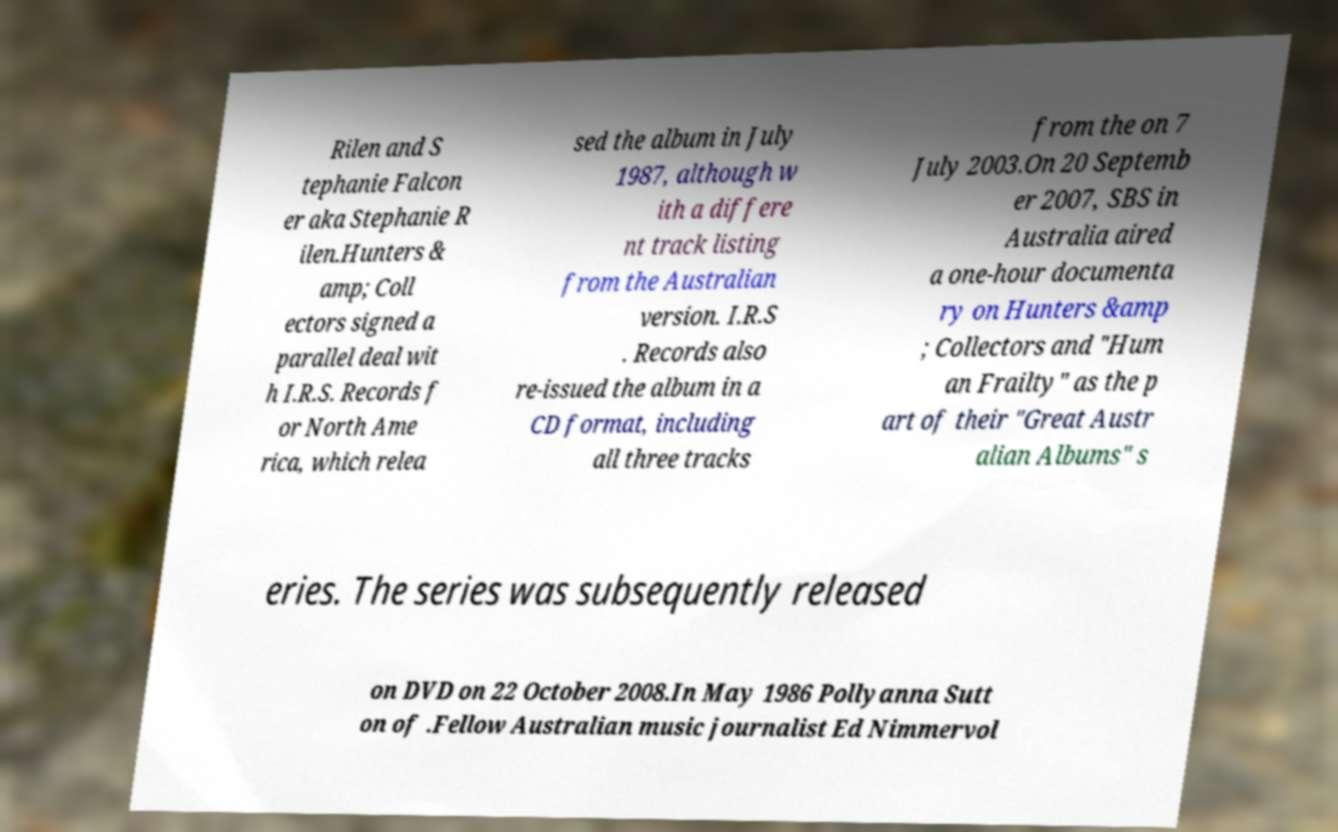There's text embedded in this image that I need extracted. Can you transcribe it verbatim? Rilen and S tephanie Falcon er aka Stephanie R ilen.Hunters & amp; Coll ectors signed a parallel deal wit h I.R.S. Records f or North Ame rica, which relea sed the album in July 1987, although w ith a differe nt track listing from the Australian version. I.R.S . Records also re-issued the album in a CD format, including all three tracks from the on 7 July 2003.On 20 Septemb er 2007, SBS in Australia aired a one-hour documenta ry on Hunters &amp ; Collectors and "Hum an Frailty" as the p art of their "Great Austr alian Albums" s eries. The series was subsequently released on DVD on 22 October 2008.In May 1986 Pollyanna Sutt on of .Fellow Australian music journalist Ed Nimmervol 